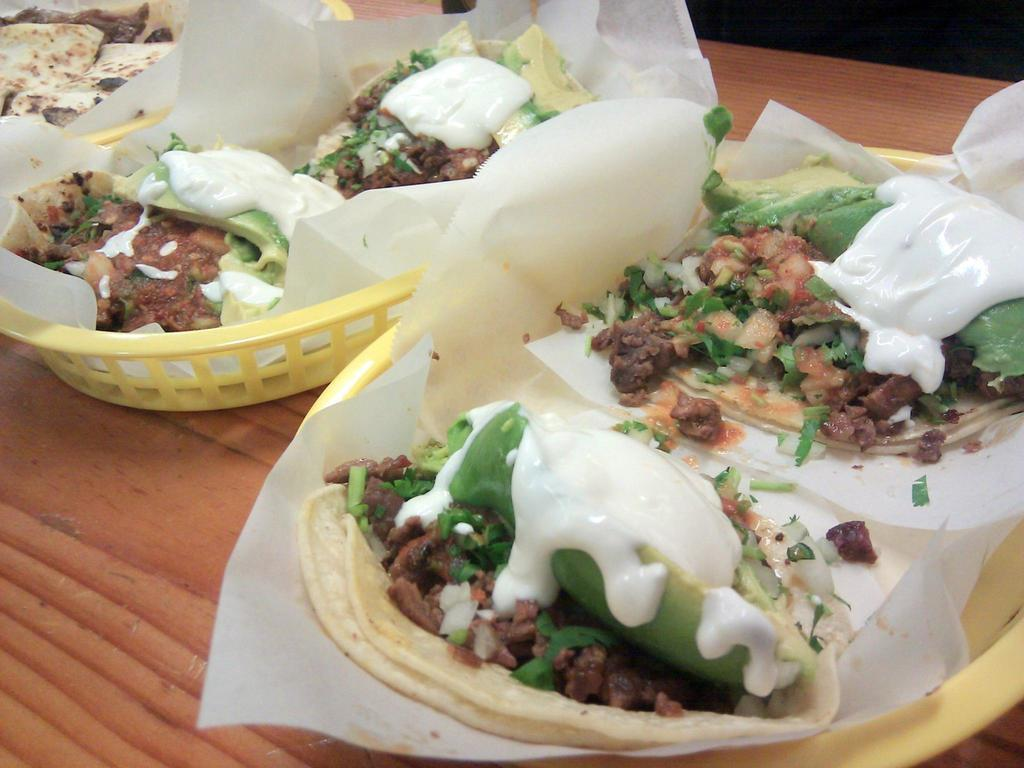What is present in the image related to food? There are food items in the image. How are the food items arranged or placed? The food items are on tissue papers. What are the tissue papers placed on? The tissue papers are on baskets. Where are the baskets located? The baskets are on a platform. Is there a throne visible in the image? No, there is no throne present in the image. 